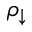<formula> <loc_0><loc_0><loc_500><loc_500>\rho _ { \downarrow }</formula> 